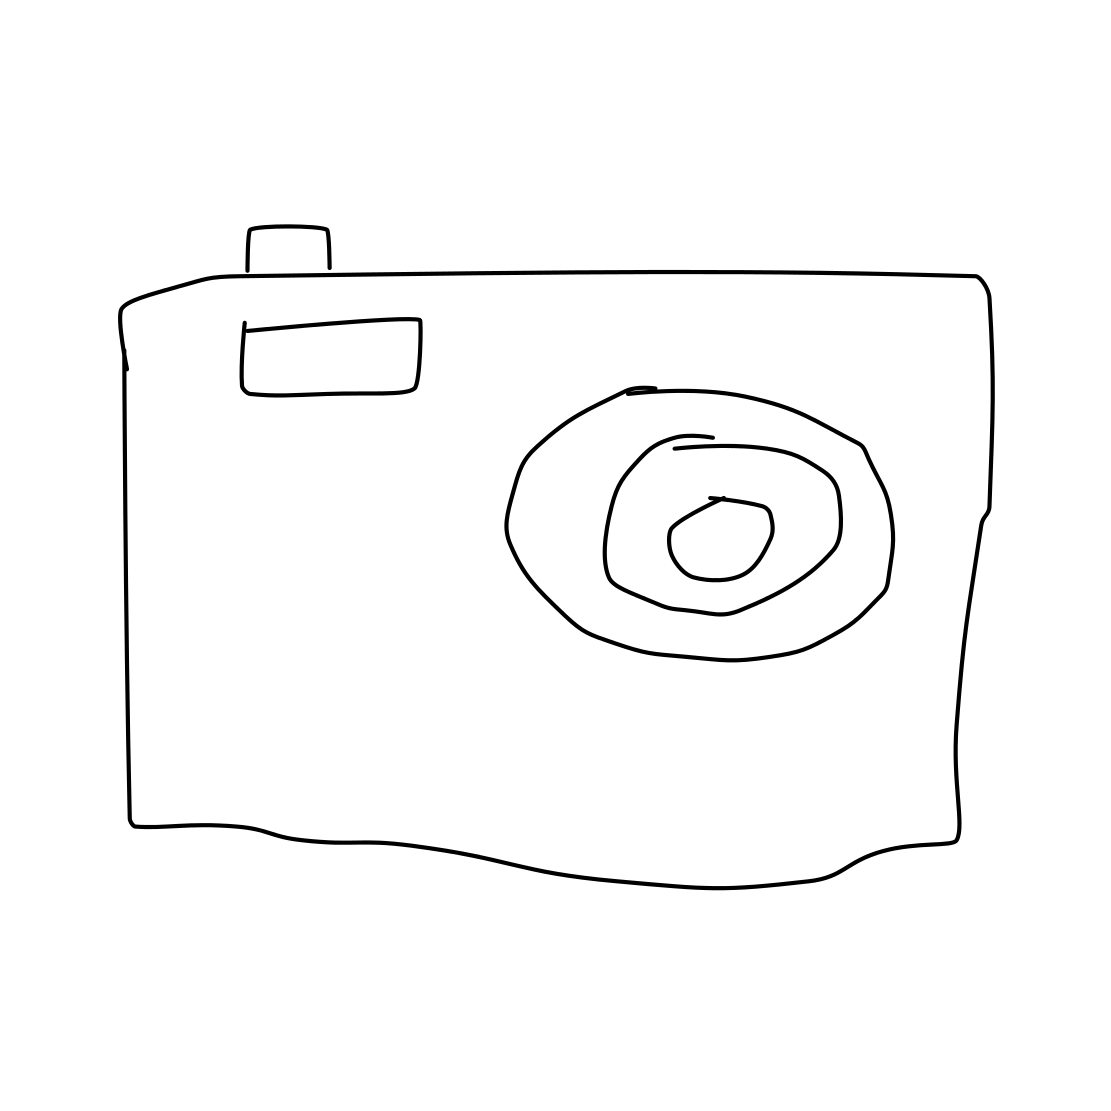Does the style of the drawing suggest anything about the artist's intentions? The minimalistic and almost child-like style of the drawing could suggest that the artist is aiming for simplicity or potentially appealing to a sense of nostalgia. It could also be a representation made to convey the essence of a camera without focusing on intricate details. 